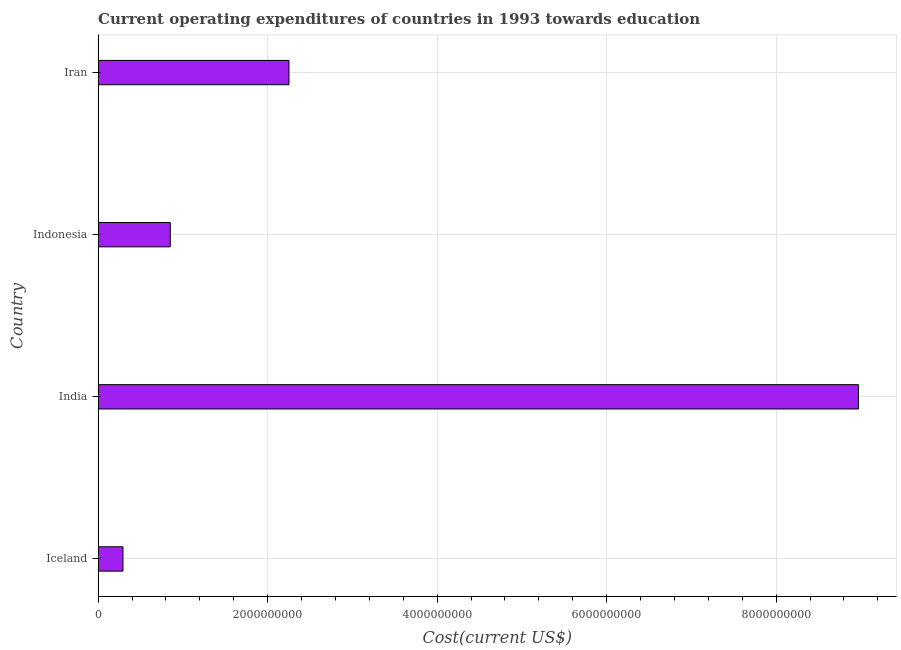Does the graph contain any zero values?
Ensure brevity in your answer.  No. Does the graph contain grids?
Provide a short and direct response. Yes. What is the title of the graph?
Your answer should be very brief. Current operating expenditures of countries in 1993 towards education. What is the label or title of the X-axis?
Provide a succinct answer. Cost(current US$). What is the label or title of the Y-axis?
Provide a short and direct response. Country. What is the education expenditure in Iran?
Provide a succinct answer. 2.25e+09. Across all countries, what is the maximum education expenditure?
Provide a short and direct response. 8.97e+09. Across all countries, what is the minimum education expenditure?
Make the answer very short. 2.93e+08. In which country was the education expenditure maximum?
Make the answer very short. India. What is the sum of the education expenditure?
Keep it short and to the point. 1.24e+1. What is the difference between the education expenditure in Indonesia and Iran?
Ensure brevity in your answer.  -1.40e+09. What is the average education expenditure per country?
Ensure brevity in your answer.  3.09e+09. What is the median education expenditure?
Your response must be concise. 1.55e+09. In how many countries, is the education expenditure greater than 5600000000 US$?
Provide a succinct answer. 1. What is the ratio of the education expenditure in Iceland to that in India?
Your response must be concise. 0.03. What is the difference between the highest and the second highest education expenditure?
Your answer should be compact. 6.72e+09. Is the sum of the education expenditure in India and Indonesia greater than the maximum education expenditure across all countries?
Your answer should be compact. Yes. What is the difference between the highest and the lowest education expenditure?
Your answer should be very brief. 8.68e+09. In how many countries, is the education expenditure greater than the average education expenditure taken over all countries?
Provide a short and direct response. 1. Are all the bars in the graph horizontal?
Keep it short and to the point. Yes. How many countries are there in the graph?
Make the answer very short. 4. Are the values on the major ticks of X-axis written in scientific E-notation?
Provide a succinct answer. No. What is the Cost(current US$) in Iceland?
Make the answer very short. 2.93e+08. What is the Cost(current US$) in India?
Give a very brief answer. 8.97e+09. What is the Cost(current US$) of Indonesia?
Your answer should be compact. 8.51e+08. What is the Cost(current US$) of Iran?
Your answer should be compact. 2.25e+09. What is the difference between the Cost(current US$) in Iceland and India?
Offer a very short reply. -8.68e+09. What is the difference between the Cost(current US$) in Iceland and Indonesia?
Ensure brevity in your answer.  -5.58e+08. What is the difference between the Cost(current US$) in Iceland and Iran?
Provide a succinct answer. -1.96e+09. What is the difference between the Cost(current US$) in India and Indonesia?
Your answer should be compact. 8.12e+09. What is the difference between the Cost(current US$) in India and Iran?
Make the answer very short. 6.72e+09. What is the difference between the Cost(current US$) in Indonesia and Iran?
Keep it short and to the point. -1.40e+09. What is the ratio of the Cost(current US$) in Iceland to that in India?
Your answer should be compact. 0.03. What is the ratio of the Cost(current US$) in Iceland to that in Indonesia?
Your answer should be compact. 0.34. What is the ratio of the Cost(current US$) in Iceland to that in Iran?
Offer a very short reply. 0.13. What is the ratio of the Cost(current US$) in India to that in Indonesia?
Provide a short and direct response. 10.54. What is the ratio of the Cost(current US$) in India to that in Iran?
Keep it short and to the point. 3.98. What is the ratio of the Cost(current US$) in Indonesia to that in Iran?
Give a very brief answer. 0.38. 